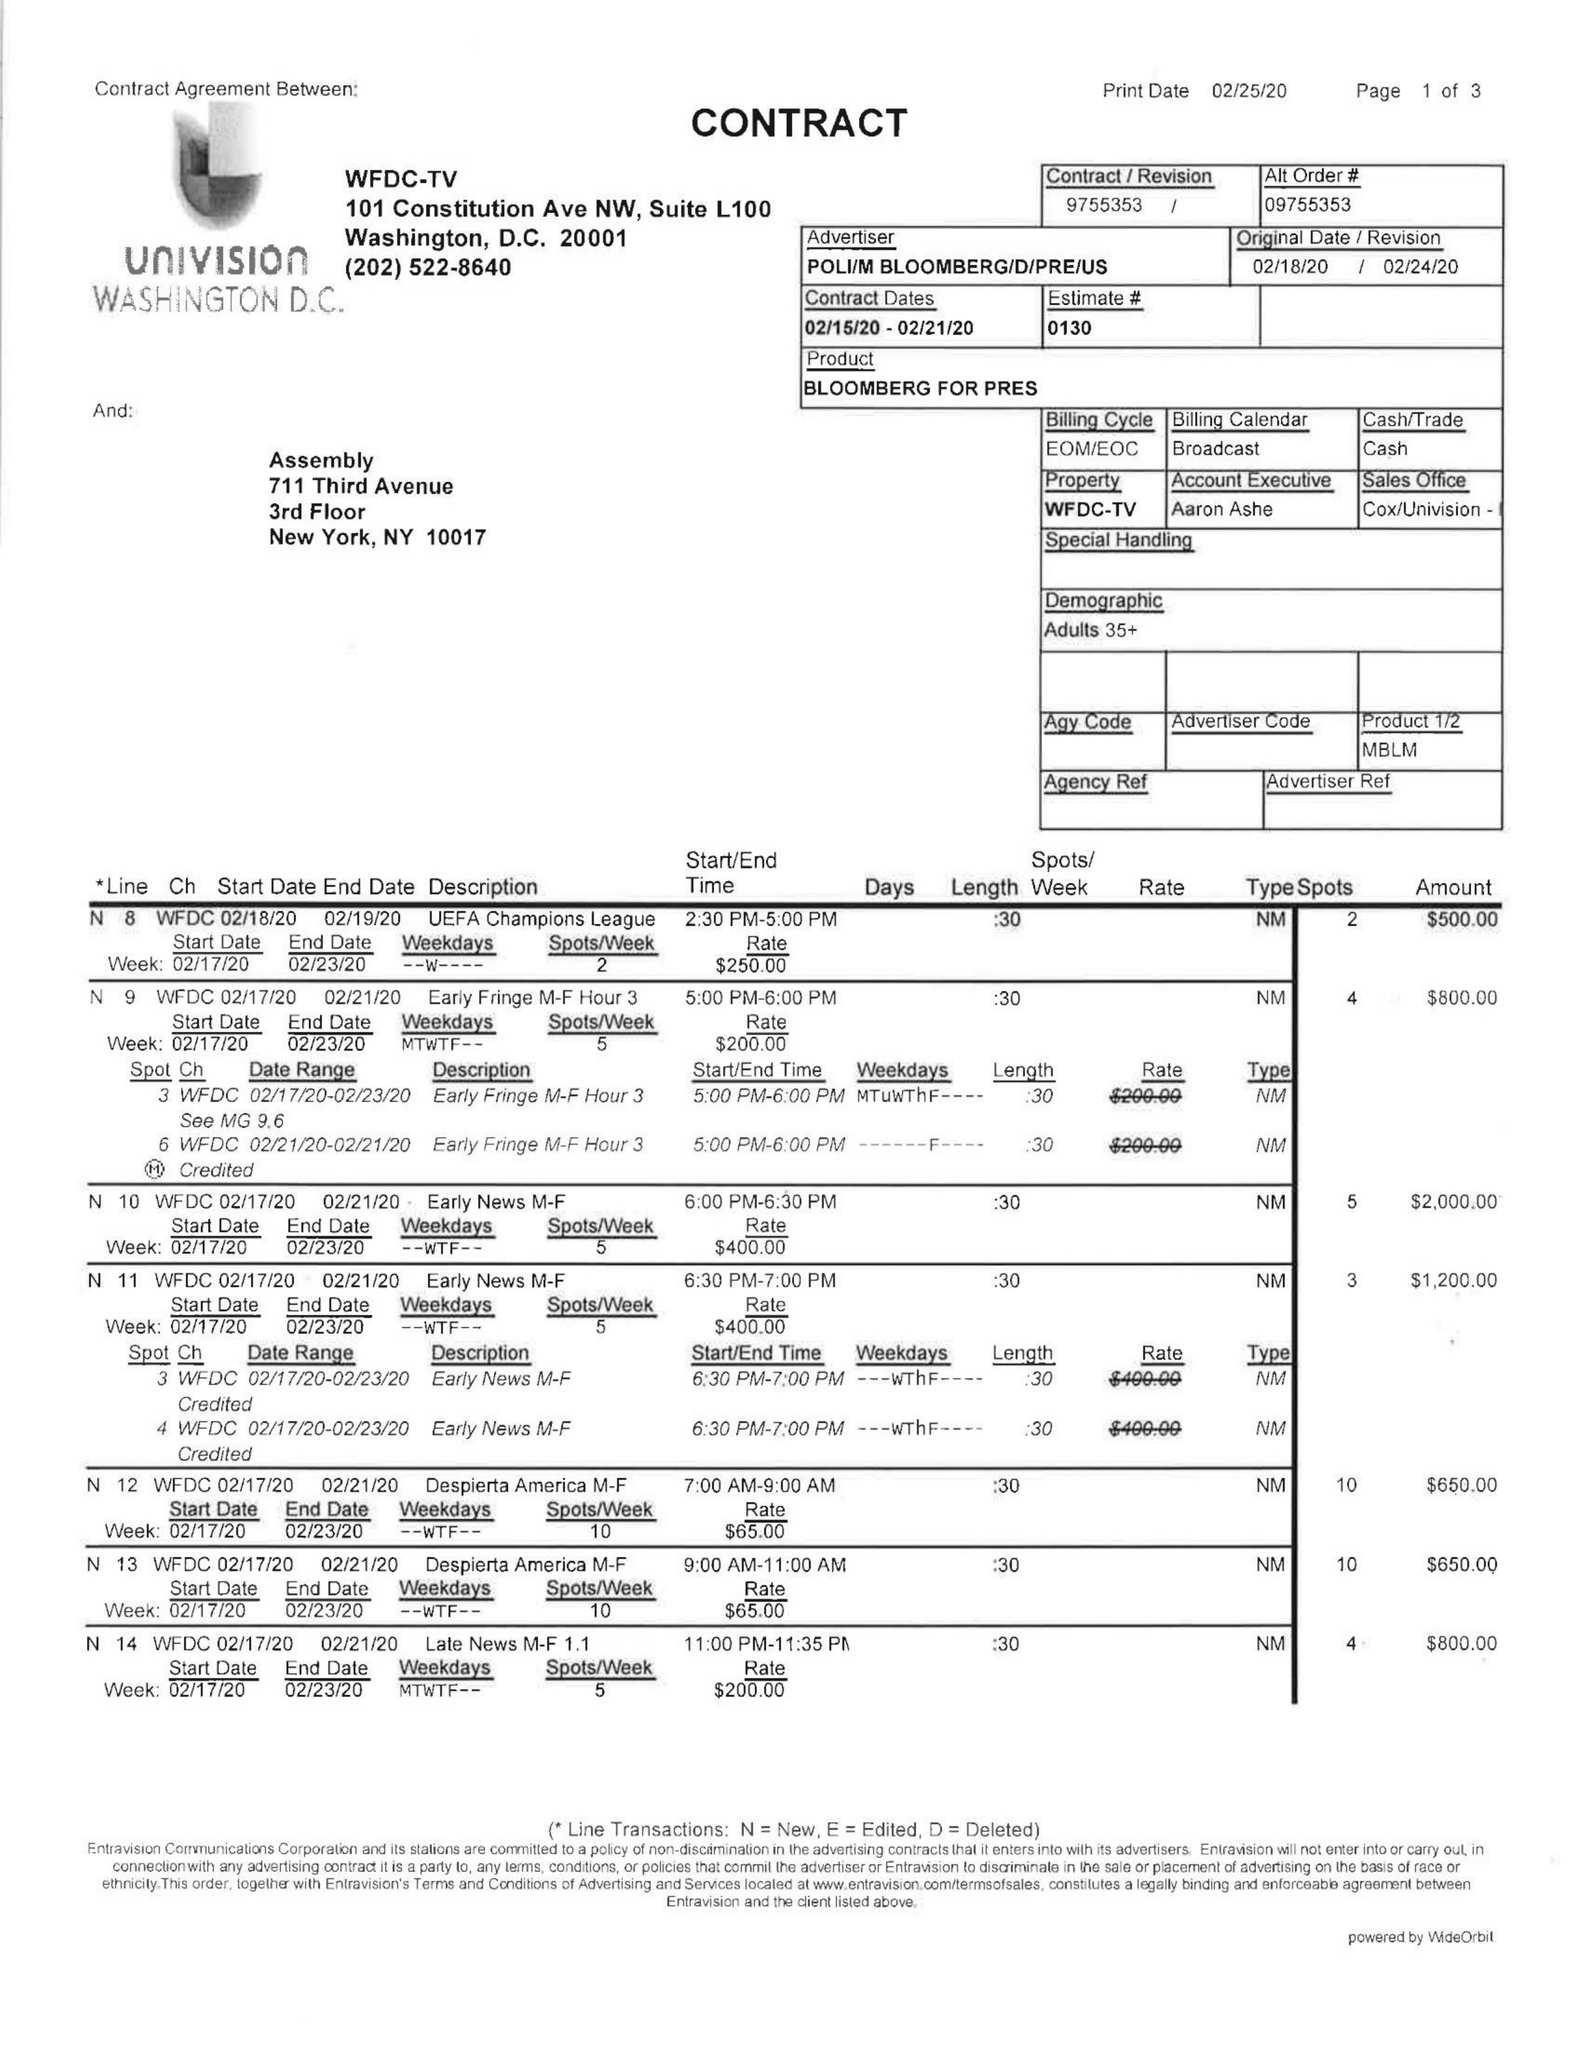What is the value for the contract_num?
Answer the question using a single word or phrase. 9755353 